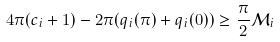<formula> <loc_0><loc_0><loc_500><loc_500>4 \pi ( c _ { i } + 1 ) - 2 \pi ( q _ { i } ( \pi ) + q _ { i } ( 0 ) ) \geq \frac { \pi } { 2 } \mathcal { M } _ { i }</formula> 